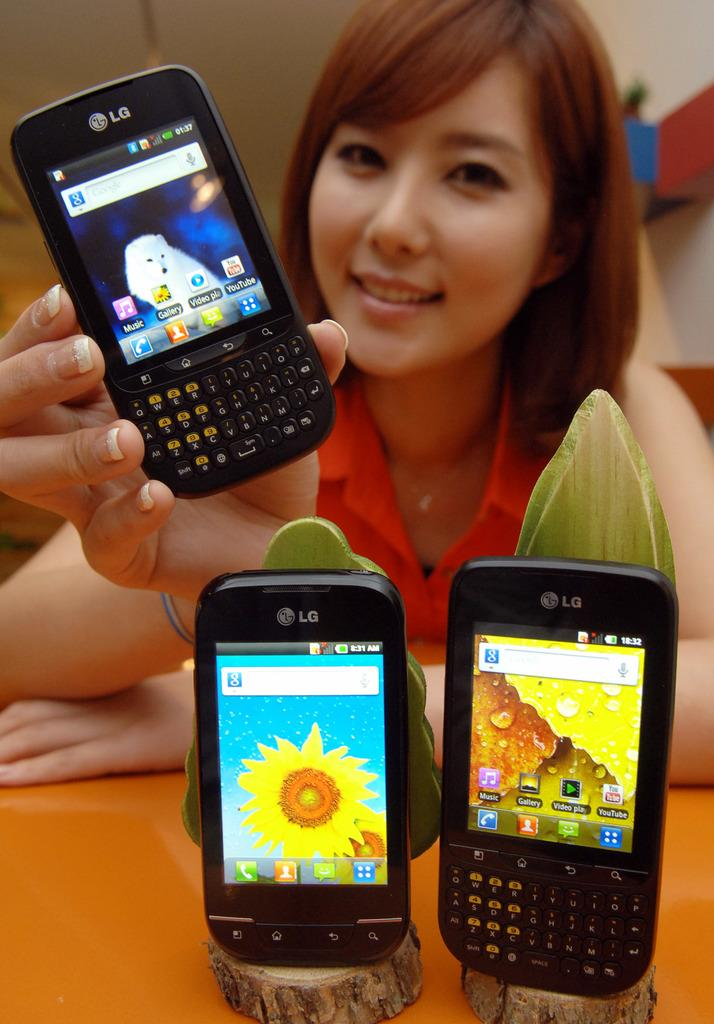Provide a one-sentence caption for the provided image. Woman holding an LG cellphone with the Music app as the first app. 